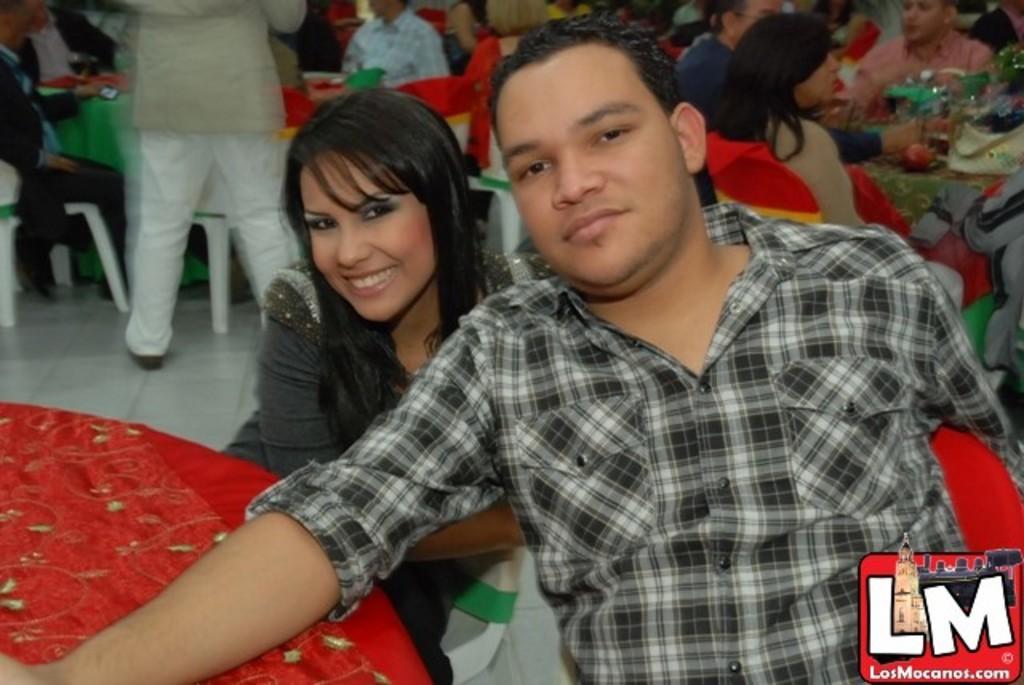Describe this image in one or two sentences. In the foreground of the picture there are chair, table, woman, man and another chair. On the right there is a logo. In the background there are people, chairs, tables, glasses and many other objects. 